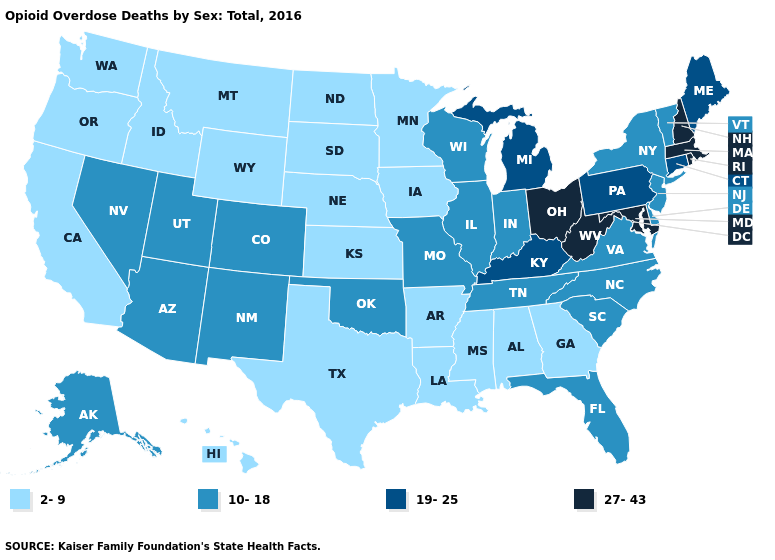Does Louisiana have the lowest value in the South?
Quick response, please. Yes. What is the value of Missouri?
Give a very brief answer. 10-18. How many symbols are there in the legend?
Concise answer only. 4. Among the states that border Idaho , does Washington have the lowest value?
Keep it brief. Yes. How many symbols are there in the legend?
Quick response, please. 4. Does the map have missing data?
Be succinct. No. What is the value of Alabama?
Write a very short answer. 2-9. What is the value of Alabama?
Short answer required. 2-9. Among the states that border Vermont , which have the lowest value?
Give a very brief answer. New York. Which states hav the highest value in the Northeast?
Write a very short answer. Massachusetts, New Hampshire, Rhode Island. Name the states that have a value in the range 19-25?
Give a very brief answer. Connecticut, Kentucky, Maine, Michigan, Pennsylvania. What is the highest value in the West ?
Answer briefly. 10-18. Which states have the highest value in the USA?
Concise answer only. Maryland, Massachusetts, New Hampshire, Ohio, Rhode Island, West Virginia. What is the value of Minnesota?
Be succinct. 2-9. What is the value of Wisconsin?
Be succinct. 10-18. 